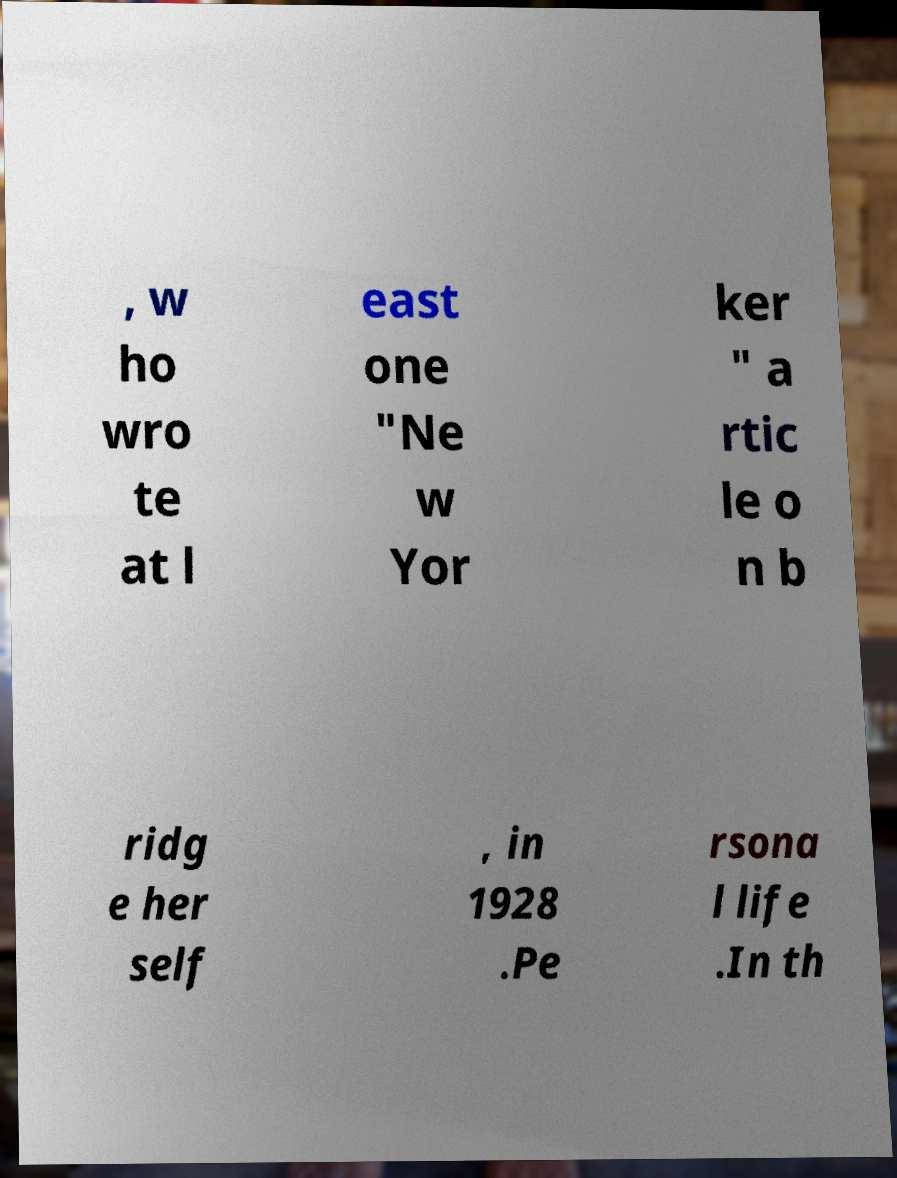I need the written content from this picture converted into text. Can you do that? , w ho wro te at l east one "Ne w Yor ker " a rtic le o n b ridg e her self , in 1928 .Pe rsona l life .In th 